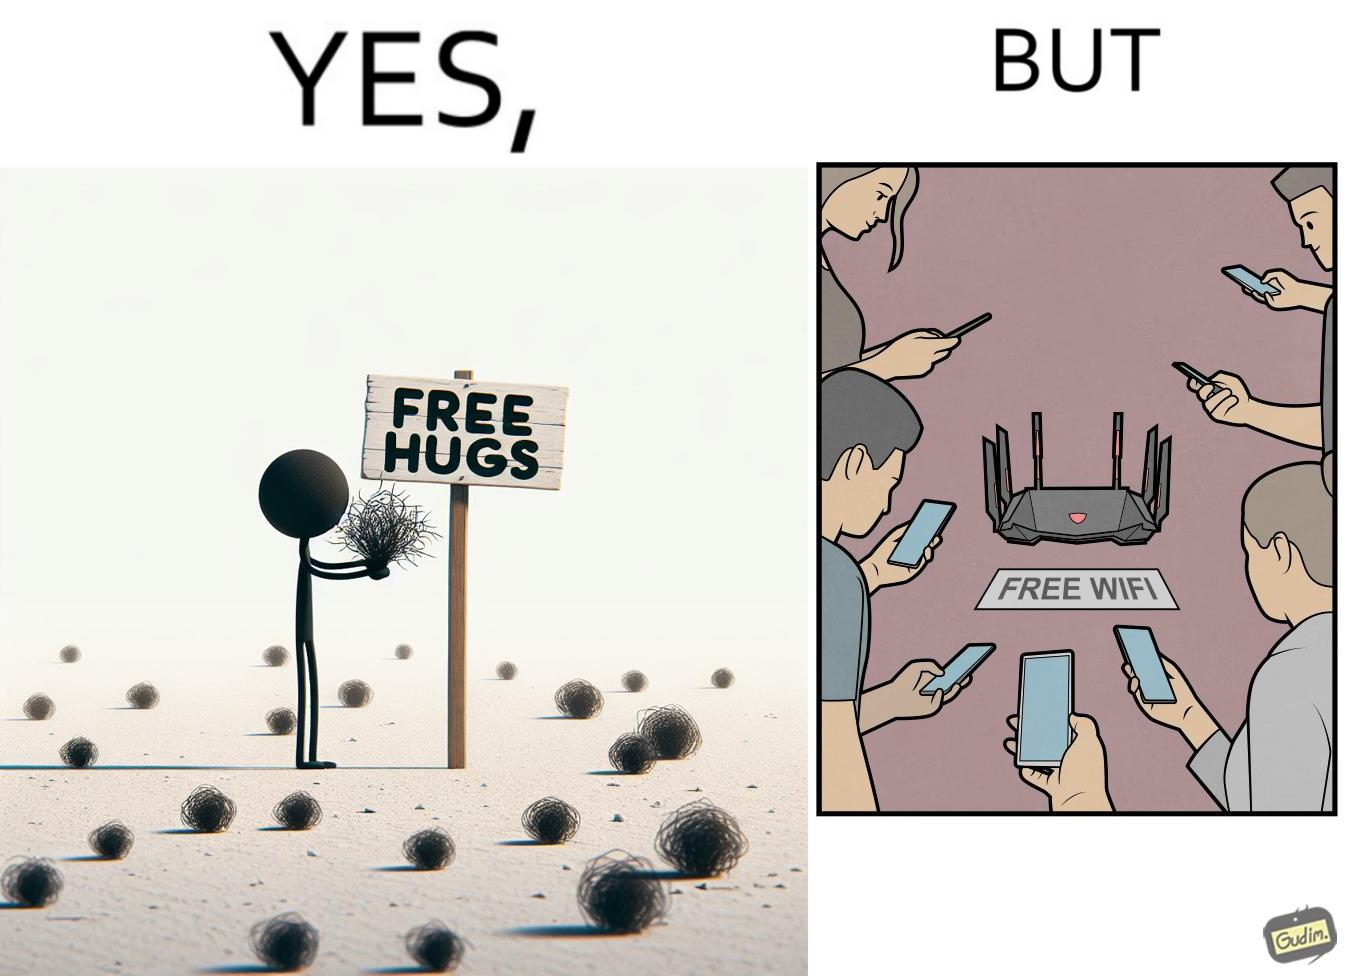Would you classify this image as satirical? Yes, this image is satirical. 